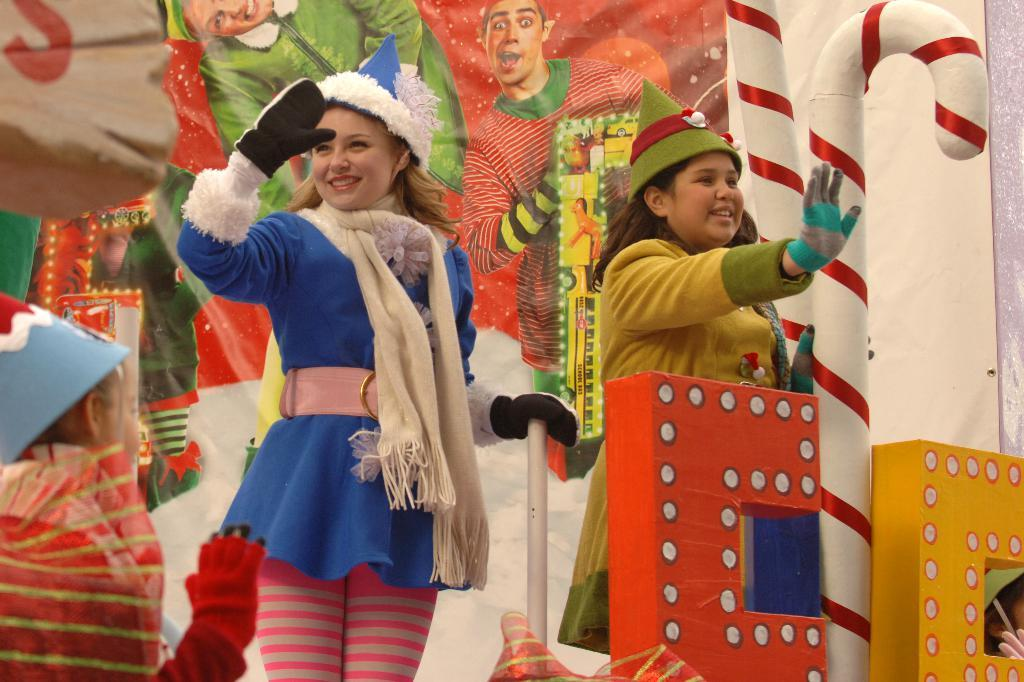How many people are present in the image? There are people in the image, but the exact number is not specified. What are some people doing in the image? Some people are holding objects in the image. What can be seen in the background of the image? There are poles and posters with images in the image. What type of decorative objects can be seen in the image? There are decorative objects in the image, but their specific nature is not described. What caption is written on the basin in the image? There is no basin present in the image, so no caption can be found on it. 